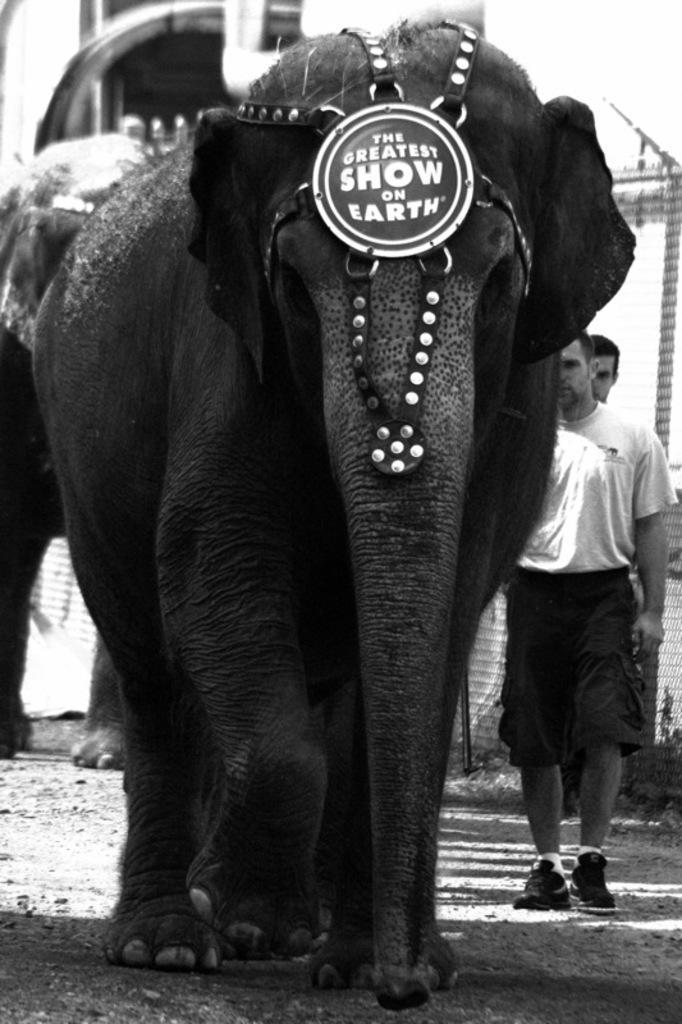How would you summarize this image in a sentence or two? This is a black and white image. There are elephants. On the elephant there is a logo with something written. In the back there are people. 